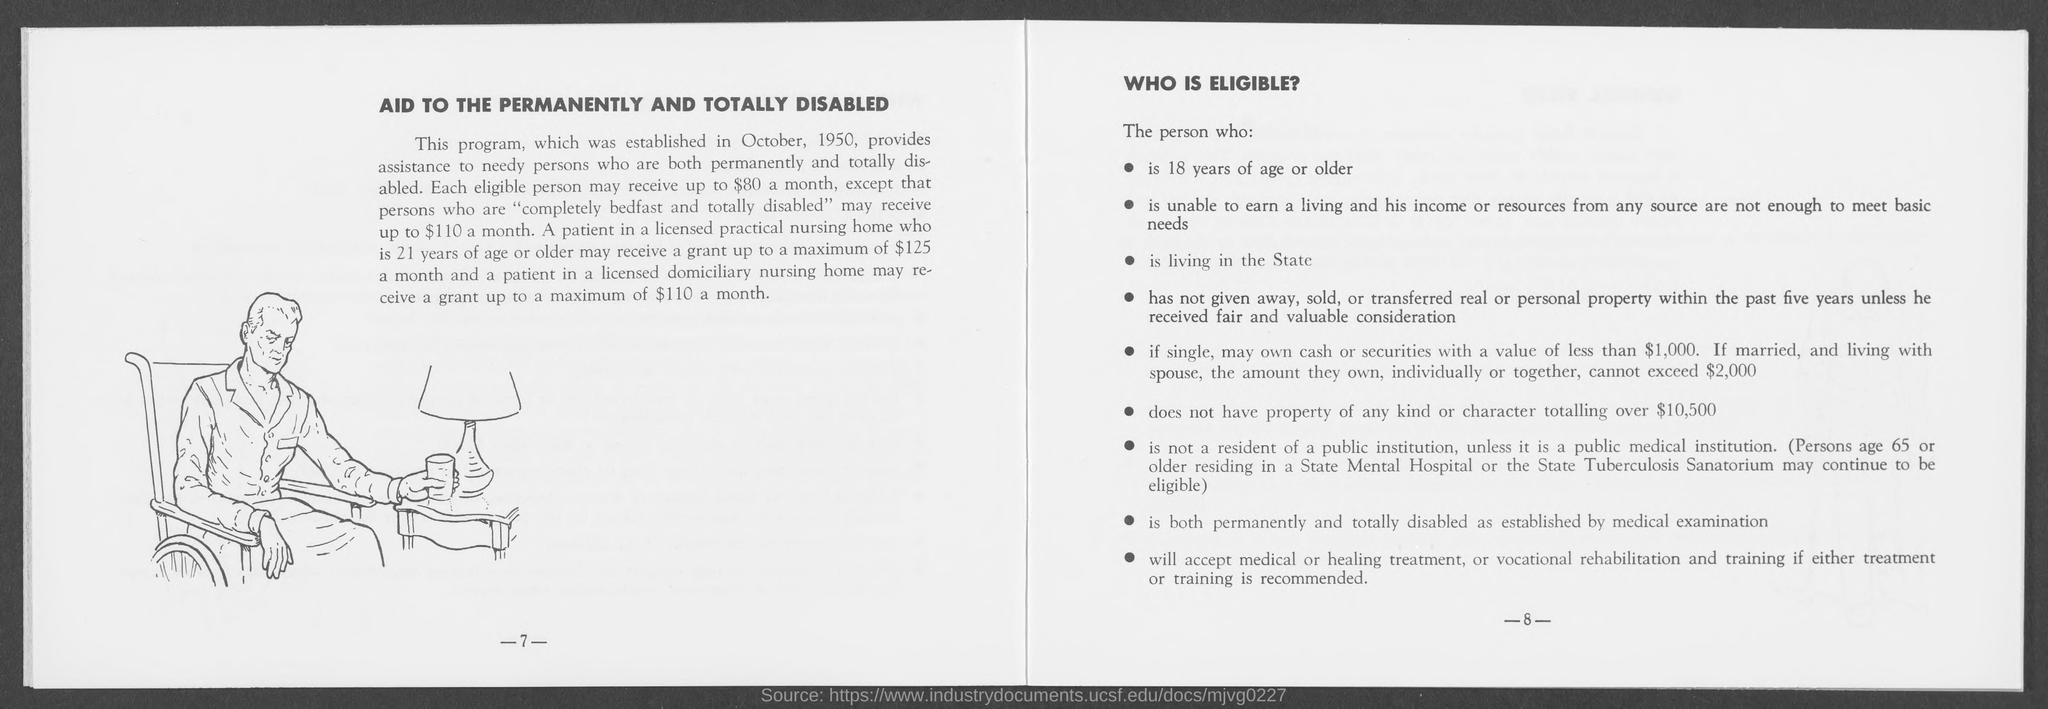Draw attention to some important aspects in this diagram. I, [name], do hereby declare that I am a person who is completely bedfast and totally disabled, and therefore eligible to receive up to $110 in monthly assistance. The amount each person will receive monthly, except for those who are totally disabled, is $80. It is not permissible for an eligible person to possess more than $10,500 worth of property of any kind or character. The program was established in October 1950. 